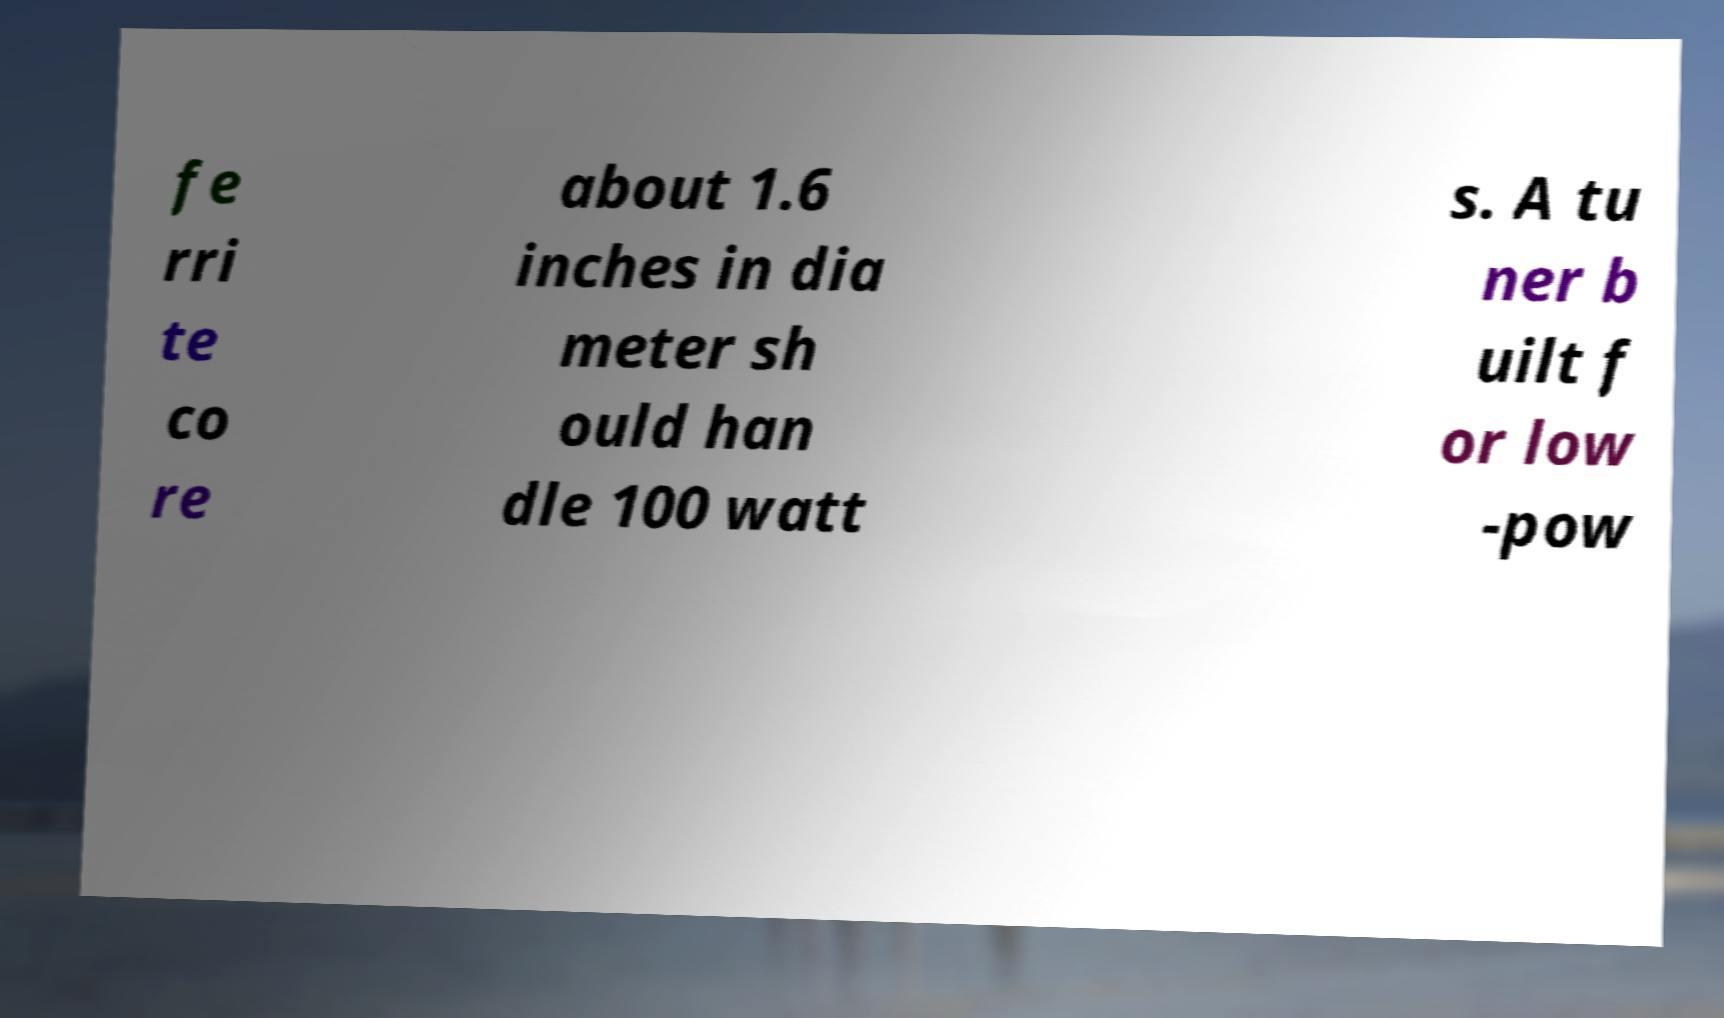There's text embedded in this image that I need extracted. Can you transcribe it verbatim? fe rri te co re about 1.6 inches in dia meter sh ould han dle 100 watt s. A tu ner b uilt f or low -pow 